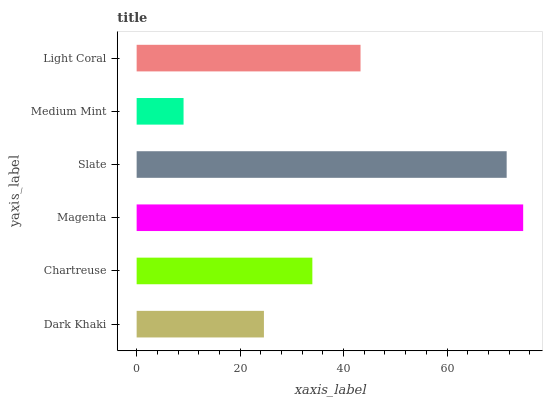Is Medium Mint the minimum?
Answer yes or no. Yes. Is Magenta the maximum?
Answer yes or no. Yes. Is Chartreuse the minimum?
Answer yes or no. No. Is Chartreuse the maximum?
Answer yes or no. No. Is Chartreuse greater than Dark Khaki?
Answer yes or no. Yes. Is Dark Khaki less than Chartreuse?
Answer yes or no. Yes. Is Dark Khaki greater than Chartreuse?
Answer yes or no. No. Is Chartreuse less than Dark Khaki?
Answer yes or no. No. Is Light Coral the high median?
Answer yes or no. Yes. Is Chartreuse the low median?
Answer yes or no. Yes. Is Magenta the high median?
Answer yes or no. No. Is Light Coral the low median?
Answer yes or no. No. 